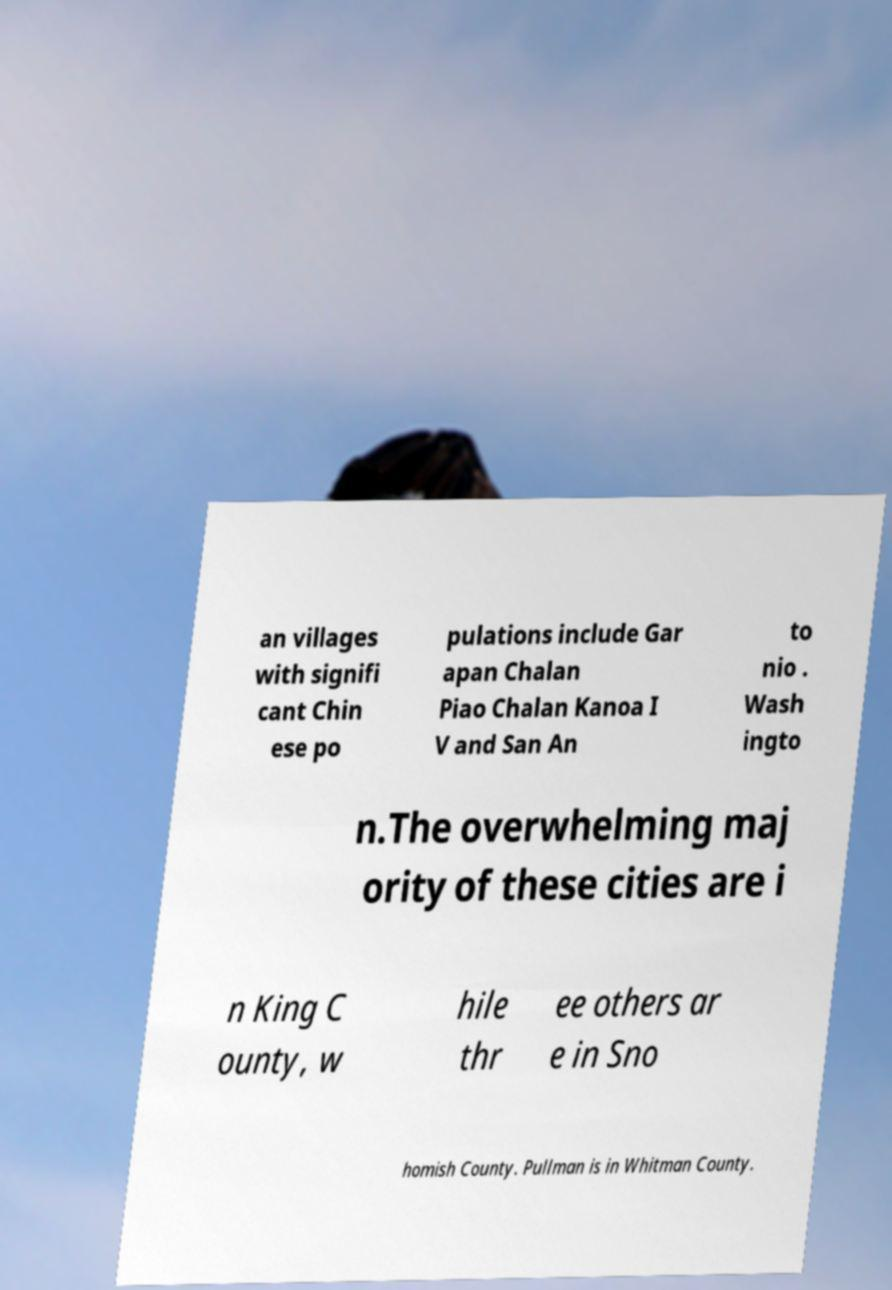What messages or text are displayed in this image? I need them in a readable, typed format. an villages with signifi cant Chin ese po pulations include Gar apan Chalan Piao Chalan Kanoa I V and San An to nio . Wash ingto n.The overwhelming maj ority of these cities are i n King C ounty, w hile thr ee others ar e in Sno homish County. Pullman is in Whitman County. 